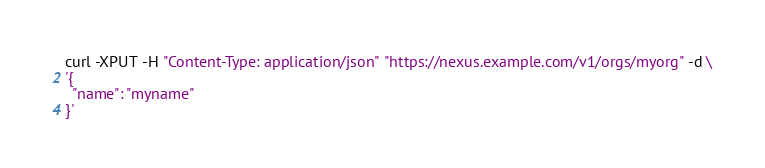<code> <loc_0><loc_0><loc_500><loc_500><_Bash_>curl -XPUT -H "Content-Type: application/json" "https://nexus.example.com/v1/orgs/myorg" -d \
'{
  "name": "myname"
}'</code> 